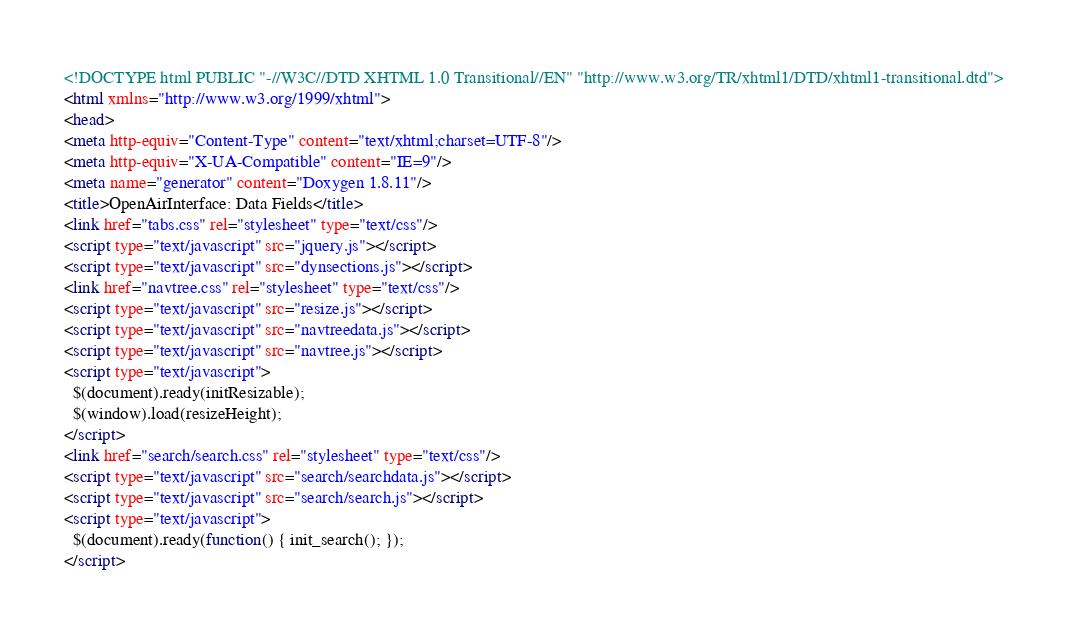Convert code to text. <code><loc_0><loc_0><loc_500><loc_500><_HTML_><!DOCTYPE html PUBLIC "-//W3C//DTD XHTML 1.0 Transitional//EN" "http://www.w3.org/TR/xhtml1/DTD/xhtml1-transitional.dtd">
<html xmlns="http://www.w3.org/1999/xhtml">
<head>
<meta http-equiv="Content-Type" content="text/xhtml;charset=UTF-8"/>
<meta http-equiv="X-UA-Compatible" content="IE=9"/>
<meta name="generator" content="Doxygen 1.8.11"/>
<title>OpenAirInterface: Data Fields</title>
<link href="tabs.css" rel="stylesheet" type="text/css"/>
<script type="text/javascript" src="jquery.js"></script>
<script type="text/javascript" src="dynsections.js"></script>
<link href="navtree.css" rel="stylesheet" type="text/css"/>
<script type="text/javascript" src="resize.js"></script>
<script type="text/javascript" src="navtreedata.js"></script>
<script type="text/javascript" src="navtree.js"></script>
<script type="text/javascript">
  $(document).ready(initResizable);
  $(window).load(resizeHeight);
</script>
<link href="search/search.css" rel="stylesheet" type="text/css"/>
<script type="text/javascript" src="search/searchdata.js"></script>
<script type="text/javascript" src="search/search.js"></script>
<script type="text/javascript">
  $(document).ready(function() { init_search(); });
</script></code> 